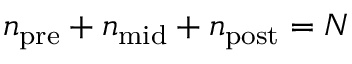Convert formula to latex. <formula><loc_0><loc_0><loc_500><loc_500>n _ { p r e } + n _ { m i d } + n _ { p o s t } = N</formula> 